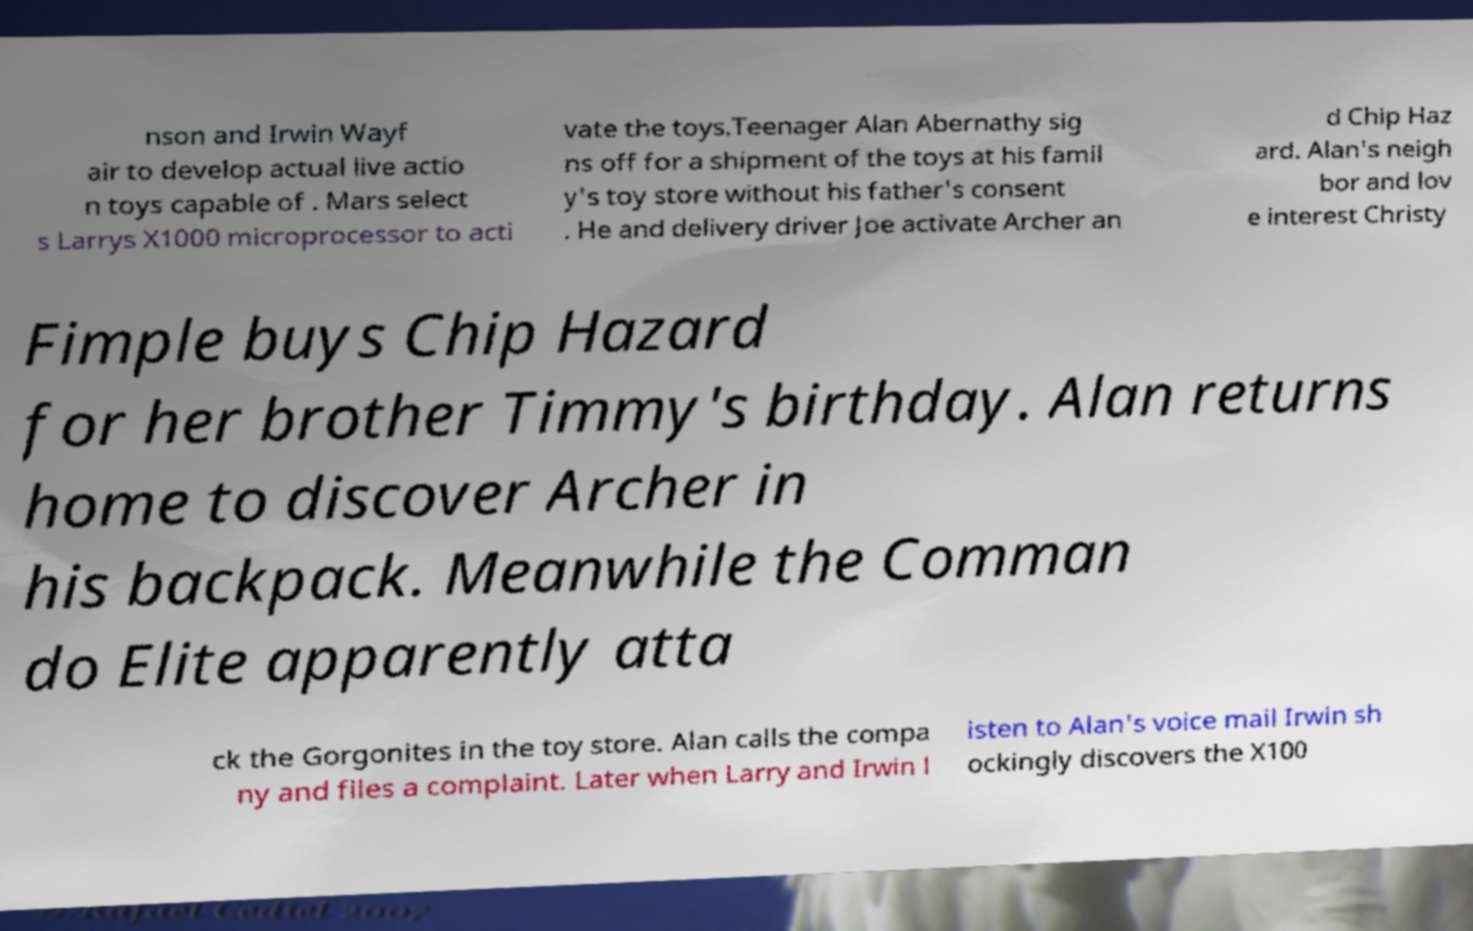Can you read and provide the text displayed in the image?This photo seems to have some interesting text. Can you extract and type it out for me? nson and Irwin Wayf air to develop actual live actio n toys capable of . Mars select s Larrys X1000 microprocessor to acti vate the toys.Teenager Alan Abernathy sig ns off for a shipment of the toys at his famil y's toy store without his father's consent . He and delivery driver Joe activate Archer an d Chip Haz ard. Alan's neigh bor and lov e interest Christy Fimple buys Chip Hazard for her brother Timmy's birthday. Alan returns home to discover Archer in his backpack. Meanwhile the Comman do Elite apparently atta ck the Gorgonites in the toy store. Alan calls the compa ny and files a complaint. Later when Larry and Irwin l isten to Alan's voice mail Irwin sh ockingly discovers the X100 